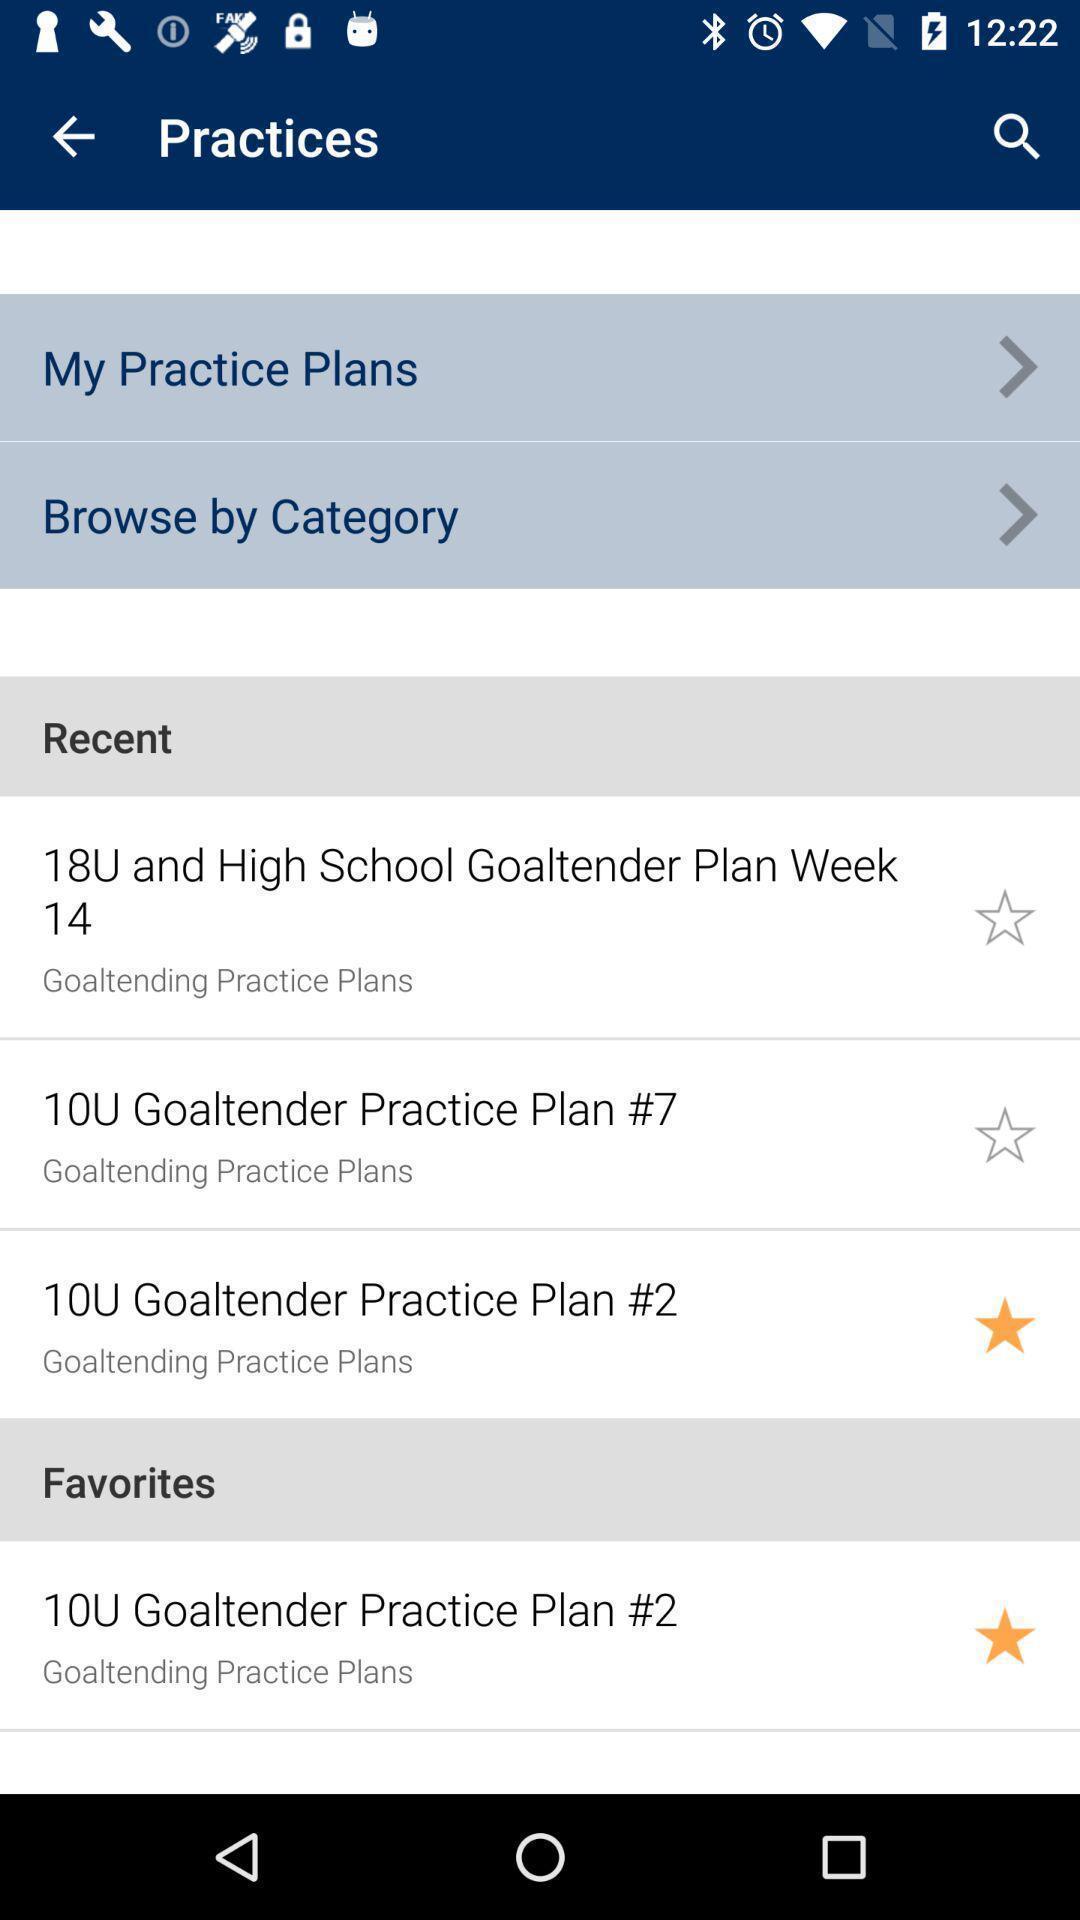Describe the content in this image. Recent and favorites of a practises. 